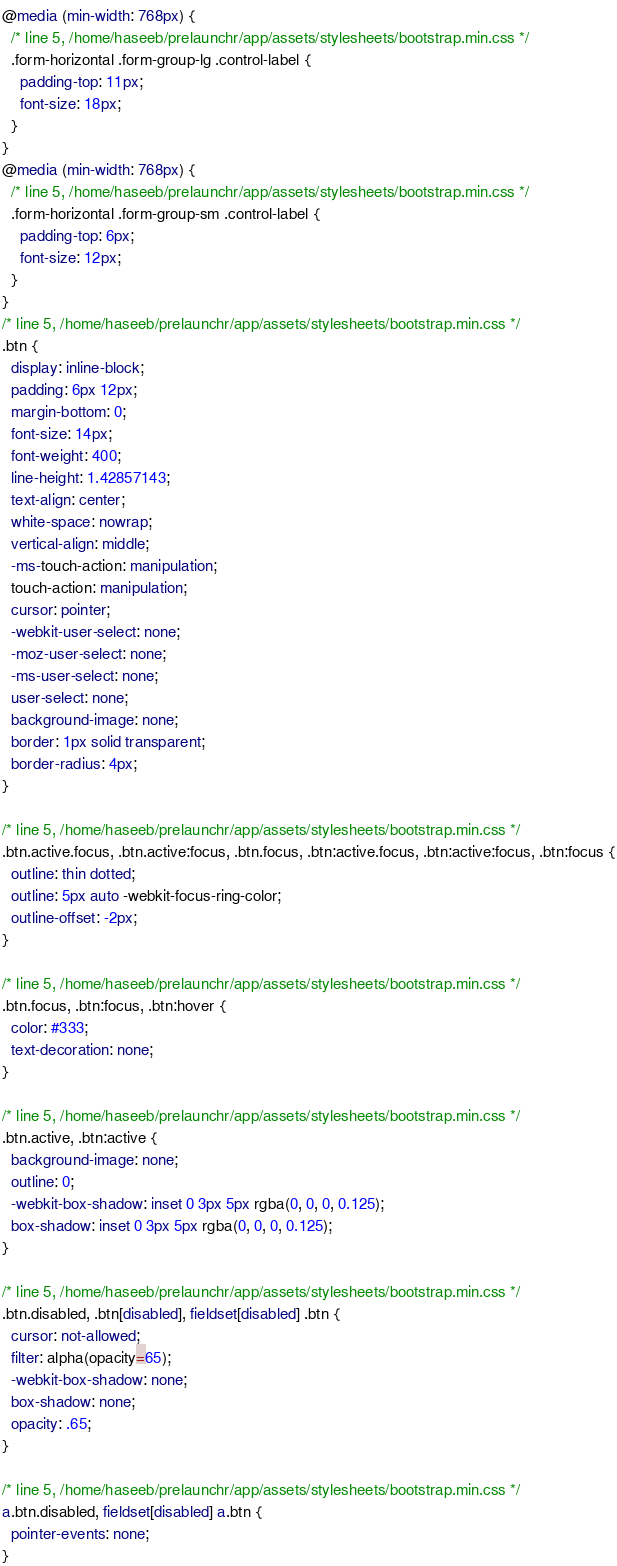Convert code to text. <code><loc_0><loc_0><loc_500><loc_500><_CSS_>
@media (min-width: 768px) {
  /* line 5, /home/haseeb/prelaunchr/app/assets/stylesheets/bootstrap.min.css */
  .form-horizontal .form-group-lg .control-label {
    padding-top: 11px;
    font-size: 18px;
  }
}
@media (min-width: 768px) {
  /* line 5, /home/haseeb/prelaunchr/app/assets/stylesheets/bootstrap.min.css */
  .form-horizontal .form-group-sm .control-label {
    padding-top: 6px;
    font-size: 12px;
  }
}
/* line 5, /home/haseeb/prelaunchr/app/assets/stylesheets/bootstrap.min.css */
.btn {
  display: inline-block;
  padding: 6px 12px;
  margin-bottom: 0;
  font-size: 14px;
  font-weight: 400;
  line-height: 1.42857143;
  text-align: center;
  white-space: nowrap;
  vertical-align: middle;
  -ms-touch-action: manipulation;
  touch-action: manipulation;
  cursor: pointer;
  -webkit-user-select: none;
  -moz-user-select: none;
  -ms-user-select: none;
  user-select: none;
  background-image: none;
  border: 1px solid transparent;
  border-radius: 4px;
}

/* line 5, /home/haseeb/prelaunchr/app/assets/stylesheets/bootstrap.min.css */
.btn.active.focus, .btn.active:focus, .btn.focus, .btn:active.focus, .btn:active:focus, .btn:focus {
  outline: thin dotted;
  outline: 5px auto -webkit-focus-ring-color;
  outline-offset: -2px;
}

/* line 5, /home/haseeb/prelaunchr/app/assets/stylesheets/bootstrap.min.css */
.btn.focus, .btn:focus, .btn:hover {
  color: #333;
  text-decoration: none;
}

/* line 5, /home/haseeb/prelaunchr/app/assets/stylesheets/bootstrap.min.css */
.btn.active, .btn:active {
  background-image: none;
  outline: 0;
  -webkit-box-shadow: inset 0 3px 5px rgba(0, 0, 0, 0.125);
  box-shadow: inset 0 3px 5px rgba(0, 0, 0, 0.125);
}

/* line 5, /home/haseeb/prelaunchr/app/assets/stylesheets/bootstrap.min.css */
.btn.disabled, .btn[disabled], fieldset[disabled] .btn {
  cursor: not-allowed;
  filter: alpha(opacity=65);
  -webkit-box-shadow: none;
  box-shadow: none;
  opacity: .65;
}

/* line 5, /home/haseeb/prelaunchr/app/assets/stylesheets/bootstrap.min.css */
a.btn.disabled, fieldset[disabled] a.btn {
  pointer-events: none;
}
</code> 